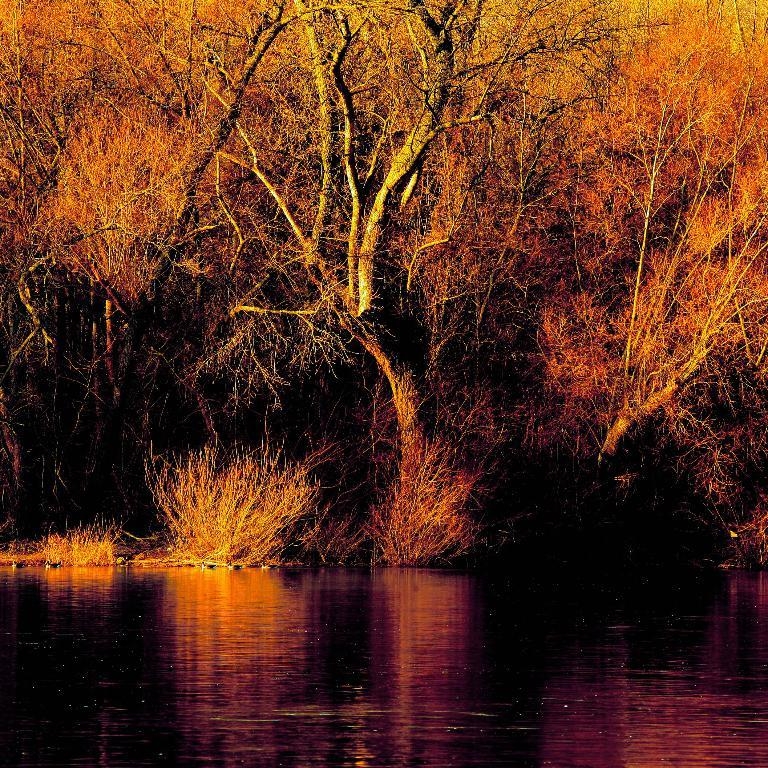What is visible in the image? Water and trees are visible in the image. Can you describe the water in the image? The water is visible, but its specific characteristics are not mentioned in the provided facts. What type of vegetation is present in the image? Trees are the type of vegetation present in the image. What type of creature can be seen using its tongue to catch fish in the image? There is no creature present in the image, and therefore no such activity can be observed. How many snakes are visible in the image? There are no snakes visible in the image; it features water and trees. 